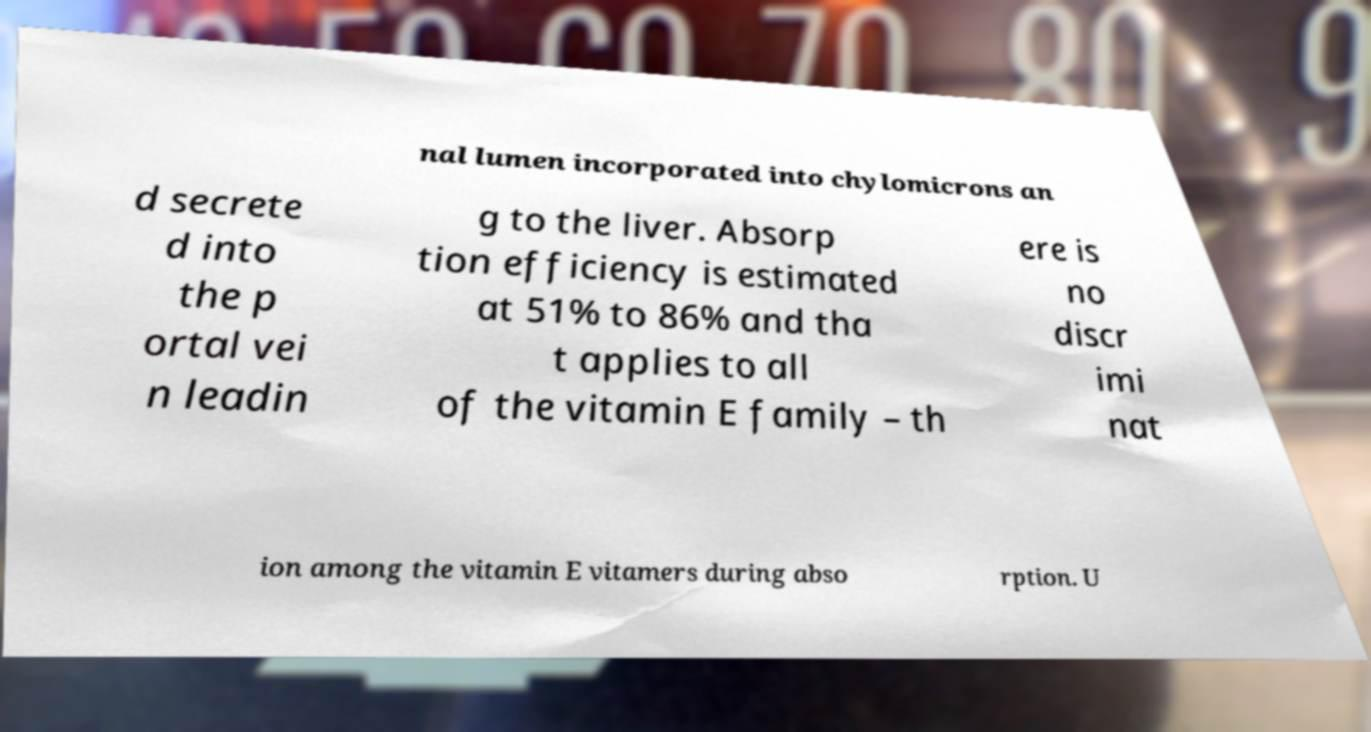Can you read and provide the text displayed in the image?This photo seems to have some interesting text. Can you extract and type it out for me? nal lumen incorporated into chylomicrons an d secrete d into the p ortal vei n leadin g to the liver. Absorp tion efficiency is estimated at 51% to 86% and tha t applies to all of the vitamin E family – th ere is no discr imi nat ion among the vitamin E vitamers during abso rption. U 